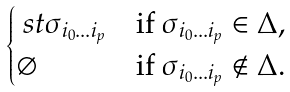<formula> <loc_0><loc_0><loc_500><loc_500>\begin{cases} \ s t { \sigma _ { i _ { 0 } \dots i _ { p } } } & \text {if $\sigma_{i_{0}\dots i_{p}}\in\Delta$,} \\ \varnothing & \text {if $\sigma_{i_{0}\dots i_{p}}\not\in\Delta$.} \end{cases}</formula> 